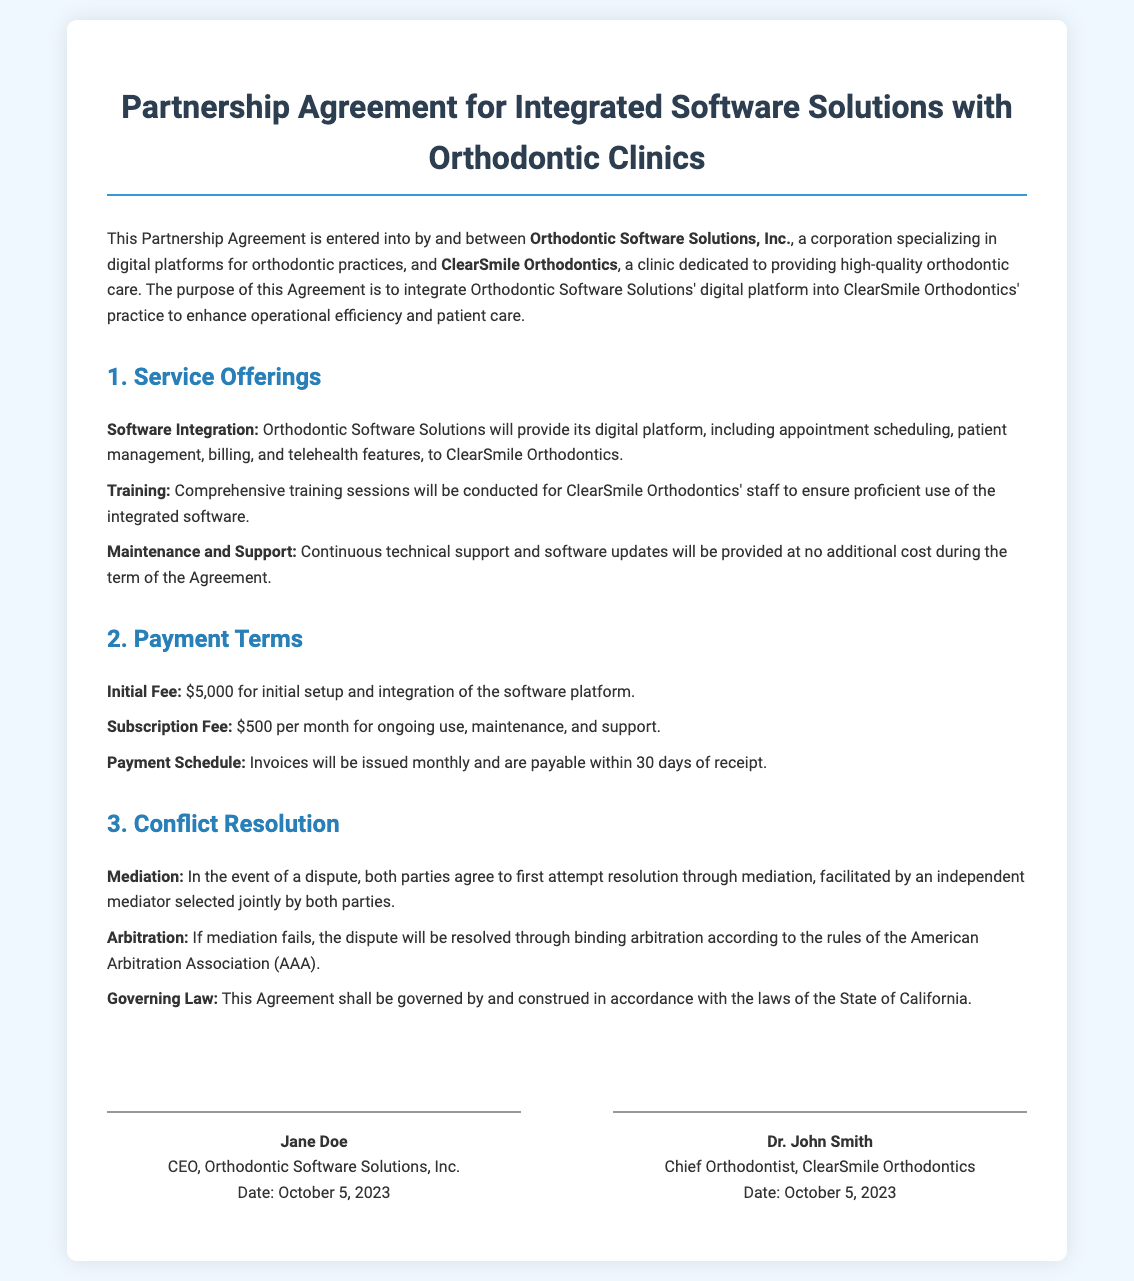What is the name of the corporation? The corporation specializing in digital platforms for orthodontic practices is named Orthodontic Software Solutions, Inc.
Answer: Orthodontic Software Solutions, Inc What is the initial fee for software integration? The initial fee for the setup and integration of the software platform is stated as $5,000.
Answer: $5,000 Who is the Chief Orthodontist at ClearSmile Orthodontics? The document identifies Dr. John Smith as the Chief Orthodontist at ClearSmile Orthodontics.
Answer: Dr. John Smith What is the monthly subscription fee? The document specifies a monthly subscription fee of $500 for ongoing use, maintenance, and support.
Answer: $500 What is the first step in dispute resolution? The first step in the event of a dispute is mediation, facilitated by an independent mediator.
Answer: Mediation What is the governing law for this agreement? The governing law for the Agreement is defined as the State of California.
Answer: State of California When was the agreement signed? The agreement was signed on October 5, 2023, as stated in the signatures section.
Answer: October 5, 2023 What type of support will be provided? The document states that continuous technical support and software updates will be provided at no additional cost during the term of the Agreement.
Answer: Continuous technical support and software updates What is the term used for legal resolution if mediation fails? If mediation fails, the document mentions that the dispute will be resolved through binding arbitration.
Answer: Binding arbitration What is included in the service offerings? The service offerings include software integration, training, and maintenance and support.
Answer: Software integration, training, maintenance and support 